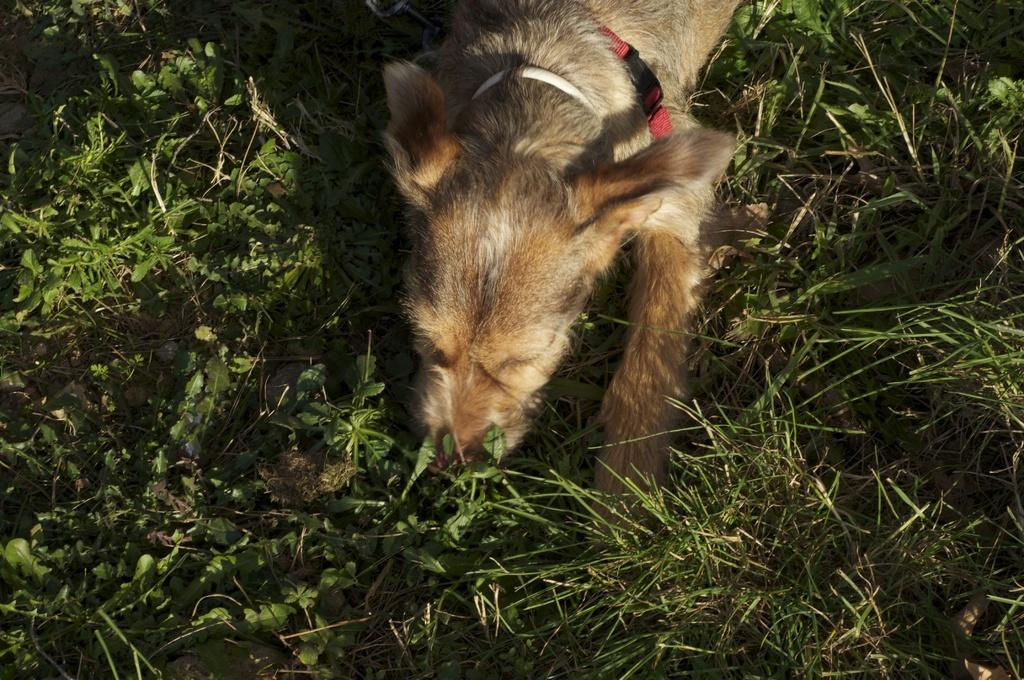What animal can be seen in the image? There is a dog in the image. What is the dog doing in the image? The dog is lying on the ground. What can be seen in the background of the image? There are plants visible in the background of the image. What type of cork can be seen in the dog's mouth in the image? There is no cork present in the image, and the dog's mouth is not visible. What phase of the moon can be seen in the image? The image does not show the moon, so it cannot be determined what phase of the moon is visible. 